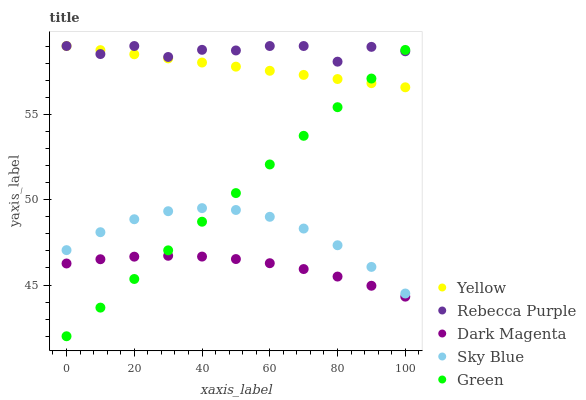Does Dark Magenta have the minimum area under the curve?
Answer yes or no. Yes. Does Rebecca Purple have the maximum area under the curve?
Answer yes or no. Yes. Does Green have the minimum area under the curve?
Answer yes or no. No. Does Green have the maximum area under the curve?
Answer yes or no. No. Is Yellow the smoothest?
Answer yes or no. Yes. Is Rebecca Purple the roughest?
Answer yes or no. Yes. Is Green the smoothest?
Answer yes or no. No. Is Green the roughest?
Answer yes or no. No. Does Green have the lowest value?
Answer yes or no. Yes. Does Rebecca Purple have the lowest value?
Answer yes or no. No. Does Yellow have the highest value?
Answer yes or no. Yes. Does Green have the highest value?
Answer yes or no. No. Is Dark Magenta less than Yellow?
Answer yes or no. Yes. Is Yellow greater than Dark Magenta?
Answer yes or no. Yes. Does Sky Blue intersect Green?
Answer yes or no. Yes. Is Sky Blue less than Green?
Answer yes or no. No. Is Sky Blue greater than Green?
Answer yes or no. No. Does Dark Magenta intersect Yellow?
Answer yes or no. No. 